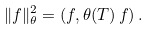<formula> <loc_0><loc_0><loc_500><loc_500>\| f \| _ { \theta } ^ { 2 } = ( f , \theta ( T ) \, f ) \, .</formula> 